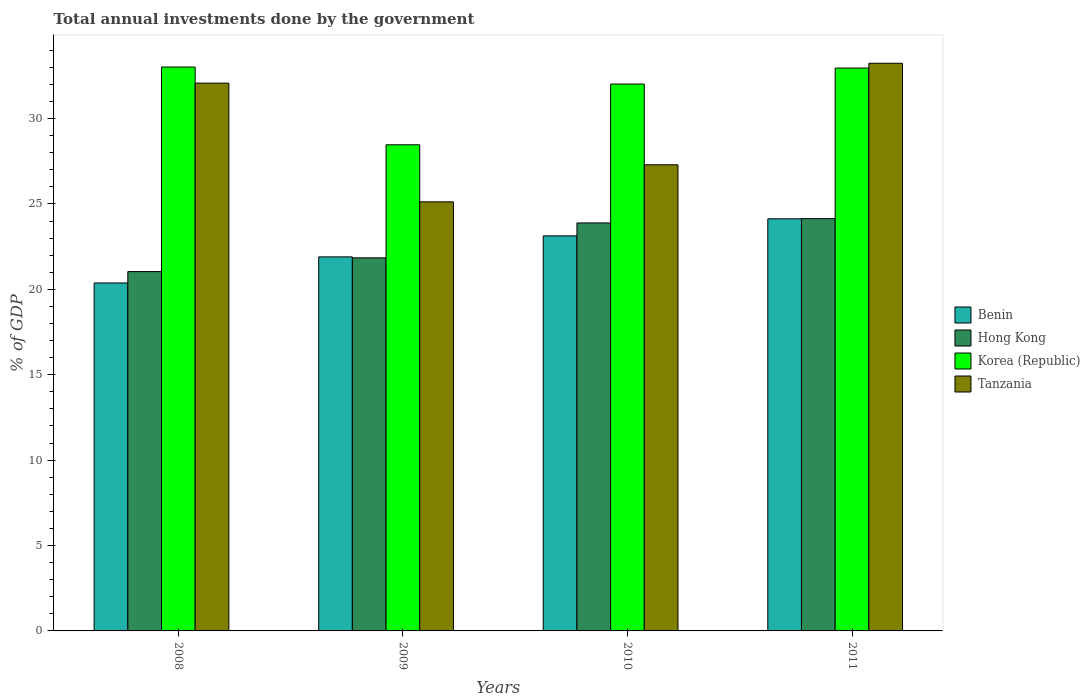Are the number of bars per tick equal to the number of legend labels?
Provide a short and direct response. Yes. How many bars are there on the 1st tick from the left?
Keep it short and to the point. 4. How many bars are there on the 1st tick from the right?
Keep it short and to the point. 4. What is the total annual investments done by the government in Benin in 2010?
Offer a very short reply. 23.13. Across all years, what is the maximum total annual investments done by the government in Tanzania?
Offer a very short reply. 33.24. Across all years, what is the minimum total annual investments done by the government in Hong Kong?
Ensure brevity in your answer.  21.04. What is the total total annual investments done by the government in Korea (Republic) in the graph?
Your answer should be compact. 126.47. What is the difference between the total annual investments done by the government in Hong Kong in 2008 and that in 2010?
Ensure brevity in your answer.  -2.85. What is the difference between the total annual investments done by the government in Hong Kong in 2011 and the total annual investments done by the government in Tanzania in 2009?
Make the answer very short. -0.98. What is the average total annual investments done by the government in Korea (Republic) per year?
Make the answer very short. 31.62. In the year 2010, what is the difference between the total annual investments done by the government in Korea (Republic) and total annual investments done by the government in Hong Kong?
Keep it short and to the point. 8.13. What is the ratio of the total annual investments done by the government in Benin in 2008 to that in 2011?
Offer a terse response. 0.84. Is the difference between the total annual investments done by the government in Korea (Republic) in 2009 and 2011 greater than the difference between the total annual investments done by the government in Hong Kong in 2009 and 2011?
Provide a short and direct response. No. What is the difference between the highest and the second highest total annual investments done by the government in Tanzania?
Your answer should be very brief. 1.16. What is the difference between the highest and the lowest total annual investments done by the government in Benin?
Make the answer very short. 3.76. Is the sum of the total annual investments done by the government in Hong Kong in 2008 and 2011 greater than the maximum total annual investments done by the government in Tanzania across all years?
Your response must be concise. Yes. Is it the case that in every year, the sum of the total annual investments done by the government in Korea (Republic) and total annual investments done by the government in Hong Kong is greater than the sum of total annual investments done by the government in Benin and total annual investments done by the government in Tanzania?
Offer a terse response. Yes. What does the 4th bar from the left in 2011 represents?
Give a very brief answer. Tanzania. What does the 3rd bar from the right in 2008 represents?
Your response must be concise. Hong Kong. Is it the case that in every year, the sum of the total annual investments done by the government in Korea (Republic) and total annual investments done by the government in Hong Kong is greater than the total annual investments done by the government in Tanzania?
Your answer should be very brief. Yes. How many bars are there?
Ensure brevity in your answer.  16. Are all the bars in the graph horizontal?
Give a very brief answer. No. Does the graph contain any zero values?
Offer a very short reply. No. Does the graph contain grids?
Make the answer very short. No. Where does the legend appear in the graph?
Provide a short and direct response. Center right. What is the title of the graph?
Give a very brief answer. Total annual investments done by the government. Does "Benin" appear as one of the legend labels in the graph?
Provide a succinct answer. Yes. What is the label or title of the Y-axis?
Give a very brief answer. % of GDP. What is the % of GDP of Benin in 2008?
Your answer should be very brief. 20.38. What is the % of GDP in Hong Kong in 2008?
Provide a succinct answer. 21.04. What is the % of GDP in Korea (Republic) in 2008?
Provide a succinct answer. 33.02. What is the % of GDP of Tanzania in 2008?
Your answer should be compact. 32.08. What is the % of GDP in Benin in 2009?
Provide a short and direct response. 21.9. What is the % of GDP of Hong Kong in 2009?
Offer a terse response. 21.85. What is the % of GDP in Korea (Republic) in 2009?
Your response must be concise. 28.47. What is the % of GDP of Tanzania in 2009?
Keep it short and to the point. 25.13. What is the % of GDP of Benin in 2010?
Make the answer very short. 23.13. What is the % of GDP of Hong Kong in 2010?
Offer a terse response. 23.89. What is the % of GDP of Korea (Republic) in 2010?
Offer a terse response. 32.02. What is the % of GDP in Tanzania in 2010?
Provide a short and direct response. 27.3. What is the % of GDP of Benin in 2011?
Keep it short and to the point. 24.13. What is the % of GDP in Hong Kong in 2011?
Provide a succinct answer. 24.14. What is the % of GDP of Korea (Republic) in 2011?
Offer a terse response. 32.96. What is the % of GDP in Tanzania in 2011?
Keep it short and to the point. 33.24. Across all years, what is the maximum % of GDP of Benin?
Ensure brevity in your answer.  24.13. Across all years, what is the maximum % of GDP of Hong Kong?
Give a very brief answer. 24.14. Across all years, what is the maximum % of GDP of Korea (Republic)?
Keep it short and to the point. 33.02. Across all years, what is the maximum % of GDP in Tanzania?
Give a very brief answer. 33.24. Across all years, what is the minimum % of GDP in Benin?
Your answer should be very brief. 20.38. Across all years, what is the minimum % of GDP of Hong Kong?
Ensure brevity in your answer.  21.04. Across all years, what is the minimum % of GDP of Korea (Republic)?
Provide a short and direct response. 28.47. Across all years, what is the minimum % of GDP in Tanzania?
Your response must be concise. 25.13. What is the total % of GDP in Benin in the graph?
Give a very brief answer. 89.54. What is the total % of GDP of Hong Kong in the graph?
Ensure brevity in your answer.  90.92. What is the total % of GDP in Korea (Republic) in the graph?
Your response must be concise. 126.47. What is the total % of GDP in Tanzania in the graph?
Give a very brief answer. 117.74. What is the difference between the % of GDP of Benin in 2008 and that in 2009?
Your answer should be compact. -1.53. What is the difference between the % of GDP in Hong Kong in 2008 and that in 2009?
Your response must be concise. -0.81. What is the difference between the % of GDP in Korea (Republic) in 2008 and that in 2009?
Your answer should be compact. 4.55. What is the difference between the % of GDP of Tanzania in 2008 and that in 2009?
Keep it short and to the point. 6.95. What is the difference between the % of GDP of Benin in 2008 and that in 2010?
Your answer should be compact. -2.76. What is the difference between the % of GDP of Hong Kong in 2008 and that in 2010?
Provide a succinct answer. -2.85. What is the difference between the % of GDP in Korea (Republic) in 2008 and that in 2010?
Offer a very short reply. 1. What is the difference between the % of GDP in Tanzania in 2008 and that in 2010?
Provide a short and direct response. 4.78. What is the difference between the % of GDP of Benin in 2008 and that in 2011?
Keep it short and to the point. -3.76. What is the difference between the % of GDP in Hong Kong in 2008 and that in 2011?
Provide a short and direct response. -3.1. What is the difference between the % of GDP in Korea (Republic) in 2008 and that in 2011?
Offer a terse response. 0.06. What is the difference between the % of GDP of Tanzania in 2008 and that in 2011?
Your answer should be compact. -1.16. What is the difference between the % of GDP in Benin in 2009 and that in 2010?
Your answer should be compact. -1.23. What is the difference between the % of GDP in Hong Kong in 2009 and that in 2010?
Your answer should be compact. -2.04. What is the difference between the % of GDP of Korea (Republic) in 2009 and that in 2010?
Provide a short and direct response. -3.56. What is the difference between the % of GDP of Tanzania in 2009 and that in 2010?
Make the answer very short. -2.17. What is the difference between the % of GDP in Benin in 2009 and that in 2011?
Make the answer very short. -2.23. What is the difference between the % of GDP in Hong Kong in 2009 and that in 2011?
Your response must be concise. -2.3. What is the difference between the % of GDP in Korea (Republic) in 2009 and that in 2011?
Ensure brevity in your answer.  -4.49. What is the difference between the % of GDP of Tanzania in 2009 and that in 2011?
Keep it short and to the point. -8.12. What is the difference between the % of GDP of Benin in 2010 and that in 2011?
Your response must be concise. -1. What is the difference between the % of GDP of Hong Kong in 2010 and that in 2011?
Ensure brevity in your answer.  -0.25. What is the difference between the % of GDP in Korea (Republic) in 2010 and that in 2011?
Keep it short and to the point. -0.94. What is the difference between the % of GDP of Tanzania in 2010 and that in 2011?
Keep it short and to the point. -5.94. What is the difference between the % of GDP in Benin in 2008 and the % of GDP in Hong Kong in 2009?
Provide a short and direct response. -1.47. What is the difference between the % of GDP in Benin in 2008 and the % of GDP in Korea (Republic) in 2009?
Your answer should be very brief. -8.09. What is the difference between the % of GDP in Benin in 2008 and the % of GDP in Tanzania in 2009?
Keep it short and to the point. -4.75. What is the difference between the % of GDP in Hong Kong in 2008 and the % of GDP in Korea (Republic) in 2009?
Provide a succinct answer. -7.42. What is the difference between the % of GDP in Hong Kong in 2008 and the % of GDP in Tanzania in 2009?
Offer a very short reply. -4.08. What is the difference between the % of GDP in Korea (Republic) in 2008 and the % of GDP in Tanzania in 2009?
Your answer should be compact. 7.89. What is the difference between the % of GDP of Benin in 2008 and the % of GDP of Hong Kong in 2010?
Offer a terse response. -3.52. What is the difference between the % of GDP in Benin in 2008 and the % of GDP in Korea (Republic) in 2010?
Provide a short and direct response. -11.65. What is the difference between the % of GDP of Benin in 2008 and the % of GDP of Tanzania in 2010?
Your response must be concise. -6.92. What is the difference between the % of GDP of Hong Kong in 2008 and the % of GDP of Korea (Republic) in 2010?
Offer a terse response. -10.98. What is the difference between the % of GDP in Hong Kong in 2008 and the % of GDP in Tanzania in 2010?
Provide a short and direct response. -6.25. What is the difference between the % of GDP of Korea (Republic) in 2008 and the % of GDP of Tanzania in 2010?
Your answer should be very brief. 5.72. What is the difference between the % of GDP of Benin in 2008 and the % of GDP of Hong Kong in 2011?
Your response must be concise. -3.77. What is the difference between the % of GDP of Benin in 2008 and the % of GDP of Korea (Republic) in 2011?
Give a very brief answer. -12.58. What is the difference between the % of GDP of Benin in 2008 and the % of GDP of Tanzania in 2011?
Keep it short and to the point. -12.87. What is the difference between the % of GDP in Hong Kong in 2008 and the % of GDP in Korea (Republic) in 2011?
Your answer should be compact. -11.92. What is the difference between the % of GDP of Hong Kong in 2008 and the % of GDP of Tanzania in 2011?
Offer a terse response. -12.2. What is the difference between the % of GDP in Korea (Republic) in 2008 and the % of GDP in Tanzania in 2011?
Provide a succinct answer. -0.22. What is the difference between the % of GDP of Benin in 2009 and the % of GDP of Hong Kong in 2010?
Your response must be concise. -1.99. What is the difference between the % of GDP in Benin in 2009 and the % of GDP in Korea (Republic) in 2010?
Offer a terse response. -10.12. What is the difference between the % of GDP in Benin in 2009 and the % of GDP in Tanzania in 2010?
Your response must be concise. -5.39. What is the difference between the % of GDP of Hong Kong in 2009 and the % of GDP of Korea (Republic) in 2010?
Provide a succinct answer. -10.18. What is the difference between the % of GDP of Hong Kong in 2009 and the % of GDP of Tanzania in 2010?
Your answer should be compact. -5.45. What is the difference between the % of GDP of Korea (Republic) in 2009 and the % of GDP of Tanzania in 2010?
Your answer should be compact. 1.17. What is the difference between the % of GDP in Benin in 2009 and the % of GDP in Hong Kong in 2011?
Your response must be concise. -2.24. What is the difference between the % of GDP of Benin in 2009 and the % of GDP of Korea (Republic) in 2011?
Ensure brevity in your answer.  -11.06. What is the difference between the % of GDP in Benin in 2009 and the % of GDP in Tanzania in 2011?
Offer a very short reply. -11.34. What is the difference between the % of GDP in Hong Kong in 2009 and the % of GDP in Korea (Republic) in 2011?
Keep it short and to the point. -11.11. What is the difference between the % of GDP in Hong Kong in 2009 and the % of GDP in Tanzania in 2011?
Offer a very short reply. -11.39. What is the difference between the % of GDP of Korea (Republic) in 2009 and the % of GDP of Tanzania in 2011?
Offer a very short reply. -4.77. What is the difference between the % of GDP in Benin in 2010 and the % of GDP in Hong Kong in 2011?
Give a very brief answer. -1.01. What is the difference between the % of GDP in Benin in 2010 and the % of GDP in Korea (Republic) in 2011?
Ensure brevity in your answer.  -9.83. What is the difference between the % of GDP in Benin in 2010 and the % of GDP in Tanzania in 2011?
Provide a succinct answer. -10.11. What is the difference between the % of GDP in Hong Kong in 2010 and the % of GDP in Korea (Republic) in 2011?
Make the answer very short. -9.07. What is the difference between the % of GDP in Hong Kong in 2010 and the % of GDP in Tanzania in 2011?
Keep it short and to the point. -9.35. What is the difference between the % of GDP of Korea (Republic) in 2010 and the % of GDP of Tanzania in 2011?
Provide a succinct answer. -1.22. What is the average % of GDP in Benin per year?
Your response must be concise. 22.39. What is the average % of GDP in Hong Kong per year?
Offer a very short reply. 22.73. What is the average % of GDP of Korea (Republic) per year?
Give a very brief answer. 31.62. What is the average % of GDP in Tanzania per year?
Offer a very short reply. 29.43. In the year 2008, what is the difference between the % of GDP in Benin and % of GDP in Hong Kong?
Your response must be concise. -0.67. In the year 2008, what is the difference between the % of GDP of Benin and % of GDP of Korea (Republic)?
Ensure brevity in your answer.  -12.64. In the year 2008, what is the difference between the % of GDP of Benin and % of GDP of Tanzania?
Give a very brief answer. -11.7. In the year 2008, what is the difference between the % of GDP in Hong Kong and % of GDP in Korea (Republic)?
Provide a short and direct response. -11.98. In the year 2008, what is the difference between the % of GDP in Hong Kong and % of GDP in Tanzania?
Provide a short and direct response. -11.03. In the year 2008, what is the difference between the % of GDP of Korea (Republic) and % of GDP of Tanzania?
Your response must be concise. 0.94. In the year 2009, what is the difference between the % of GDP of Benin and % of GDP of Hong Kong?
Ensure brevity in your answer.  0.06. In the year 2009, what is the difference between the % of GDP in Benin and % of GDP in Korea (Republic)?
Offer a terse response. -6.56. In the year 2009, what is the difference between the % of GDP in Benin and % of GDP in Tanzania?
Your answer should be very brief. -3.22. In the year 2009, what is the difference between the % of GDP in Hong Kong and % of GDP in Korea (Republic)?
Your response must be concise. -6.62. In the year 2009, what is the difference between the % of GDP of Hong Kong and % of GDP of Tanzania?
Provide a succinct answer. -3.28. In the year 2009, what is the difference between the % of GDP of Korea (Republic) and % of GDP of Tanzania?
Your answer should be very brief. 3.34. In the year 2010, what is the difference between the % of GDP in Benin and % of GDP in Hong Kong?
Ensure brevity in your answer.  -0.76. In the year 2010, what is the difference between the % of GDP in Benin and % of GDP in Korea (Republic)?
Provide a short and direct response. -8.89. In the year 2010, what is the difference between the % of GDP of Benin and % of GDP of Tanzania?
Ensure brevity in your answer.  -4.16. In the year 2010, what is the difference between the % of GDP of Hong Kong and % of GDP of Korea (Republic)?
Provide a succinct answer. -8.13. In the year 2010, what is the difference between the % of GDP in Hong Kong and % of GDP in Tanzania?
Keep it short and to the point. -3.41. In the year 2010, what is the difference between the % of GDP in Korea (Republic) and % of GDP in Tanzania?
Give a very brief answer. 4.73. In the year 2011, what is the difference between the % of GDP in Benin and % of GDP in Hong Kong?
Give a very brief answer. -0.01. In the year 2011, what is the difference between the % of GDP of Benin and % of GDP of Korea (Republic)?
Offer a terse response. -8.83. In the year 2011, what is the difference between the % of GDP in Benin and % of GDP in Tanzania?
Keep it short and to the point. -9.11. In the year 2011, what is the difference between the % of GDP in Hong Kong and % of GDP in Korea (Republic)?
Your answer should be compact. -8.82. In the year 2011, what is the difference between the % of GDP of Hong Kong and % of GDP of Tanzania?
Offer a very short reply. -9.1. In the year 2011, what is the difference between the % of GDP in Korea (Republic) and % of GDP in Tanzania?
Ensure brevity in your answer.  -0.28. What is the ratio of the % of GDP in Benin in 2008 to that in 2009?
Make the answer very short. 0.93. What is the ratio of the % of GDP in Hong Kong in 2008 to that in 2009?
Offer a very short reply. 0.96. What is the ratio of the % of GDP of Korea (Republic) in 2008 to that in 2009?
Provide a short and direct response. 1.16. What is the ratio of the % of GDP in Tanzania in 2008 to that in 2009?
Make the answer very short. 1.28. What is the ratio of the % of GDP of Benin in 2008 to that in 2010?
Offer a very short reply. 0.88. What is the ratio of the % of GDP of Hong Kong in 2008 to that in 2010?
Offer a very short reply. 0.88. What is the ratio of the % of GDP in Korea (Republic) in 2008 to that in 2010?
Ensure brevity in your answer.  1.03. What is the ratio of the % of GDP in Tanzania in 2008 to that in 2010?
Keep it short and to the point. 1.18. What is the ratio of the % of GDP in Benin in 2008 to that in 2011?
Provide a succinct answer. 0.84. What is the ratio of the % of GDP of Hong Kong in 2008 to that in 2011?
Provide a succinct answer. 0.87. What is the ratio of the % of GDP in Benin in 2009 to that in 2010?
Make the answer very short. 0.95. What is the ratio of the % of GDP in Hong Kong in 2009 to that in 2010?
Offer a terse response. 0.91. What is the ratio of the % of GDP of Tanzania in 2009 to that in 2010?
Your answer should be very brief. 0.92. What is the ratio of the % of GDP of Benin in 2009 to that in 2011?
Offer a terse response. 0.91. What is the ratio of the % of GDP in Hong Kong in 2009 to that in 2011?
Provide a short and direct response. 0.9. What is the ratio of the % of GDP in Korea (Republic) in 2009 to that in 2011?
Your answer should be very brief. 0.86. What is the ratio of the % of GDP of Tanzania in 2009 to that in 2011?
Ensure brevity in your answer.  0.76. What is the ratio of the % of GDP of Benin in 2010 to that in 2011?
Provide a short and direct response. 0.96. What is the ratio of the % of GDP of Hong Kong in 2010 to that in 2011?
Your answer should be compact. 0.99. What is the ratio of the % of GDP in Korea (Republic) in 2010 to that in 2011?
Your answer should be very brief. 0.97. What is the ratio of the % of GDP of Tanzania in 2010 to that in 2011?
Your answer should be compact. 0.82. What is the difference between the highest and the second highest % of GDP in Benin?
Make the answer very short. 1. What is the difference between the highest and the second highest % of GDP in Hong Kong?
Keep it short and to the point. 0.25. What is the difference between the highest and the second highest % of GDP in Korea (Republic)?
Ensure brevity in your answer.  0.06. What is the difference between the highest and the second highest % of GDP in Tanzania?
Make the answer very short. 1.16. What is the difference between the highest and the lowest % of GDP in Benin?
Your response must be concise. 3.76. What is the difference between the highest and the lowest % of GDP of Hong Kong?
Keep it short and to the point. 3.1. What is the difference between the highest and the lowest % of GDP of Korea (Republic)?
Make the answer very short. 4.55. What is the difference between the highest and the lowest % of GDP in Tanzania?
Offer a terse response. 8.12. 